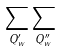<formula> <loc_0><loc_0><loc_500><loc_500>\sum _ { Q ^ { \prime } _ { w } } \sum _ { Q ^ { \prime \prime } _ { w } }</formula> 